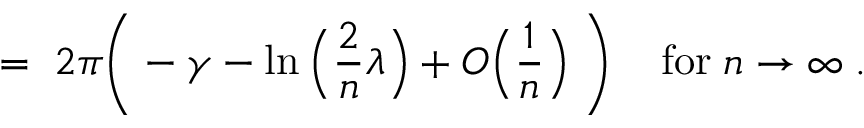Convert formula to latex. <formula><loc_0><loc_0><loc_500><loc_500>= \, 2 \pi \left ( - \gamma - \ln \left ( \frac { 2 } { n } \lambda \right ) + O \left ( \frac { 1 } { n } \right ) \, \right ) \, f o r \, n \rightarrow \infty \, .</formula> 